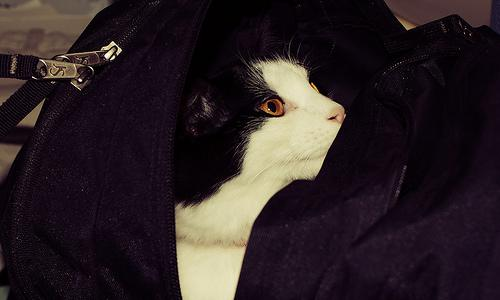Question: what is in the bag?
Choices:
A. Books.
B. Papers.
C. A cat.
D. Pens.
Answer with the letter. Answer: C Question: what color is the cat?
Choices:
A. Green.
B. Black and white.
C. Blue.
D. Yellow.
Answer with the letter. Answer: B Question: how many cats are in picture?
Choices:
A. One.
B. Two.
C. Three.
D. Four.
Answer with the letter. Answer: A Question: what color is the bag?
Choices:
A. Green.
B. Blue.
C. Black.
D. Yellow.
Answer with the letter. Answer: C Question: what color is the cat's nose?
Choices:
A. Green.
B. Blue.
C. Red.
D. Pink.
Answer with the letter. Answer: D 